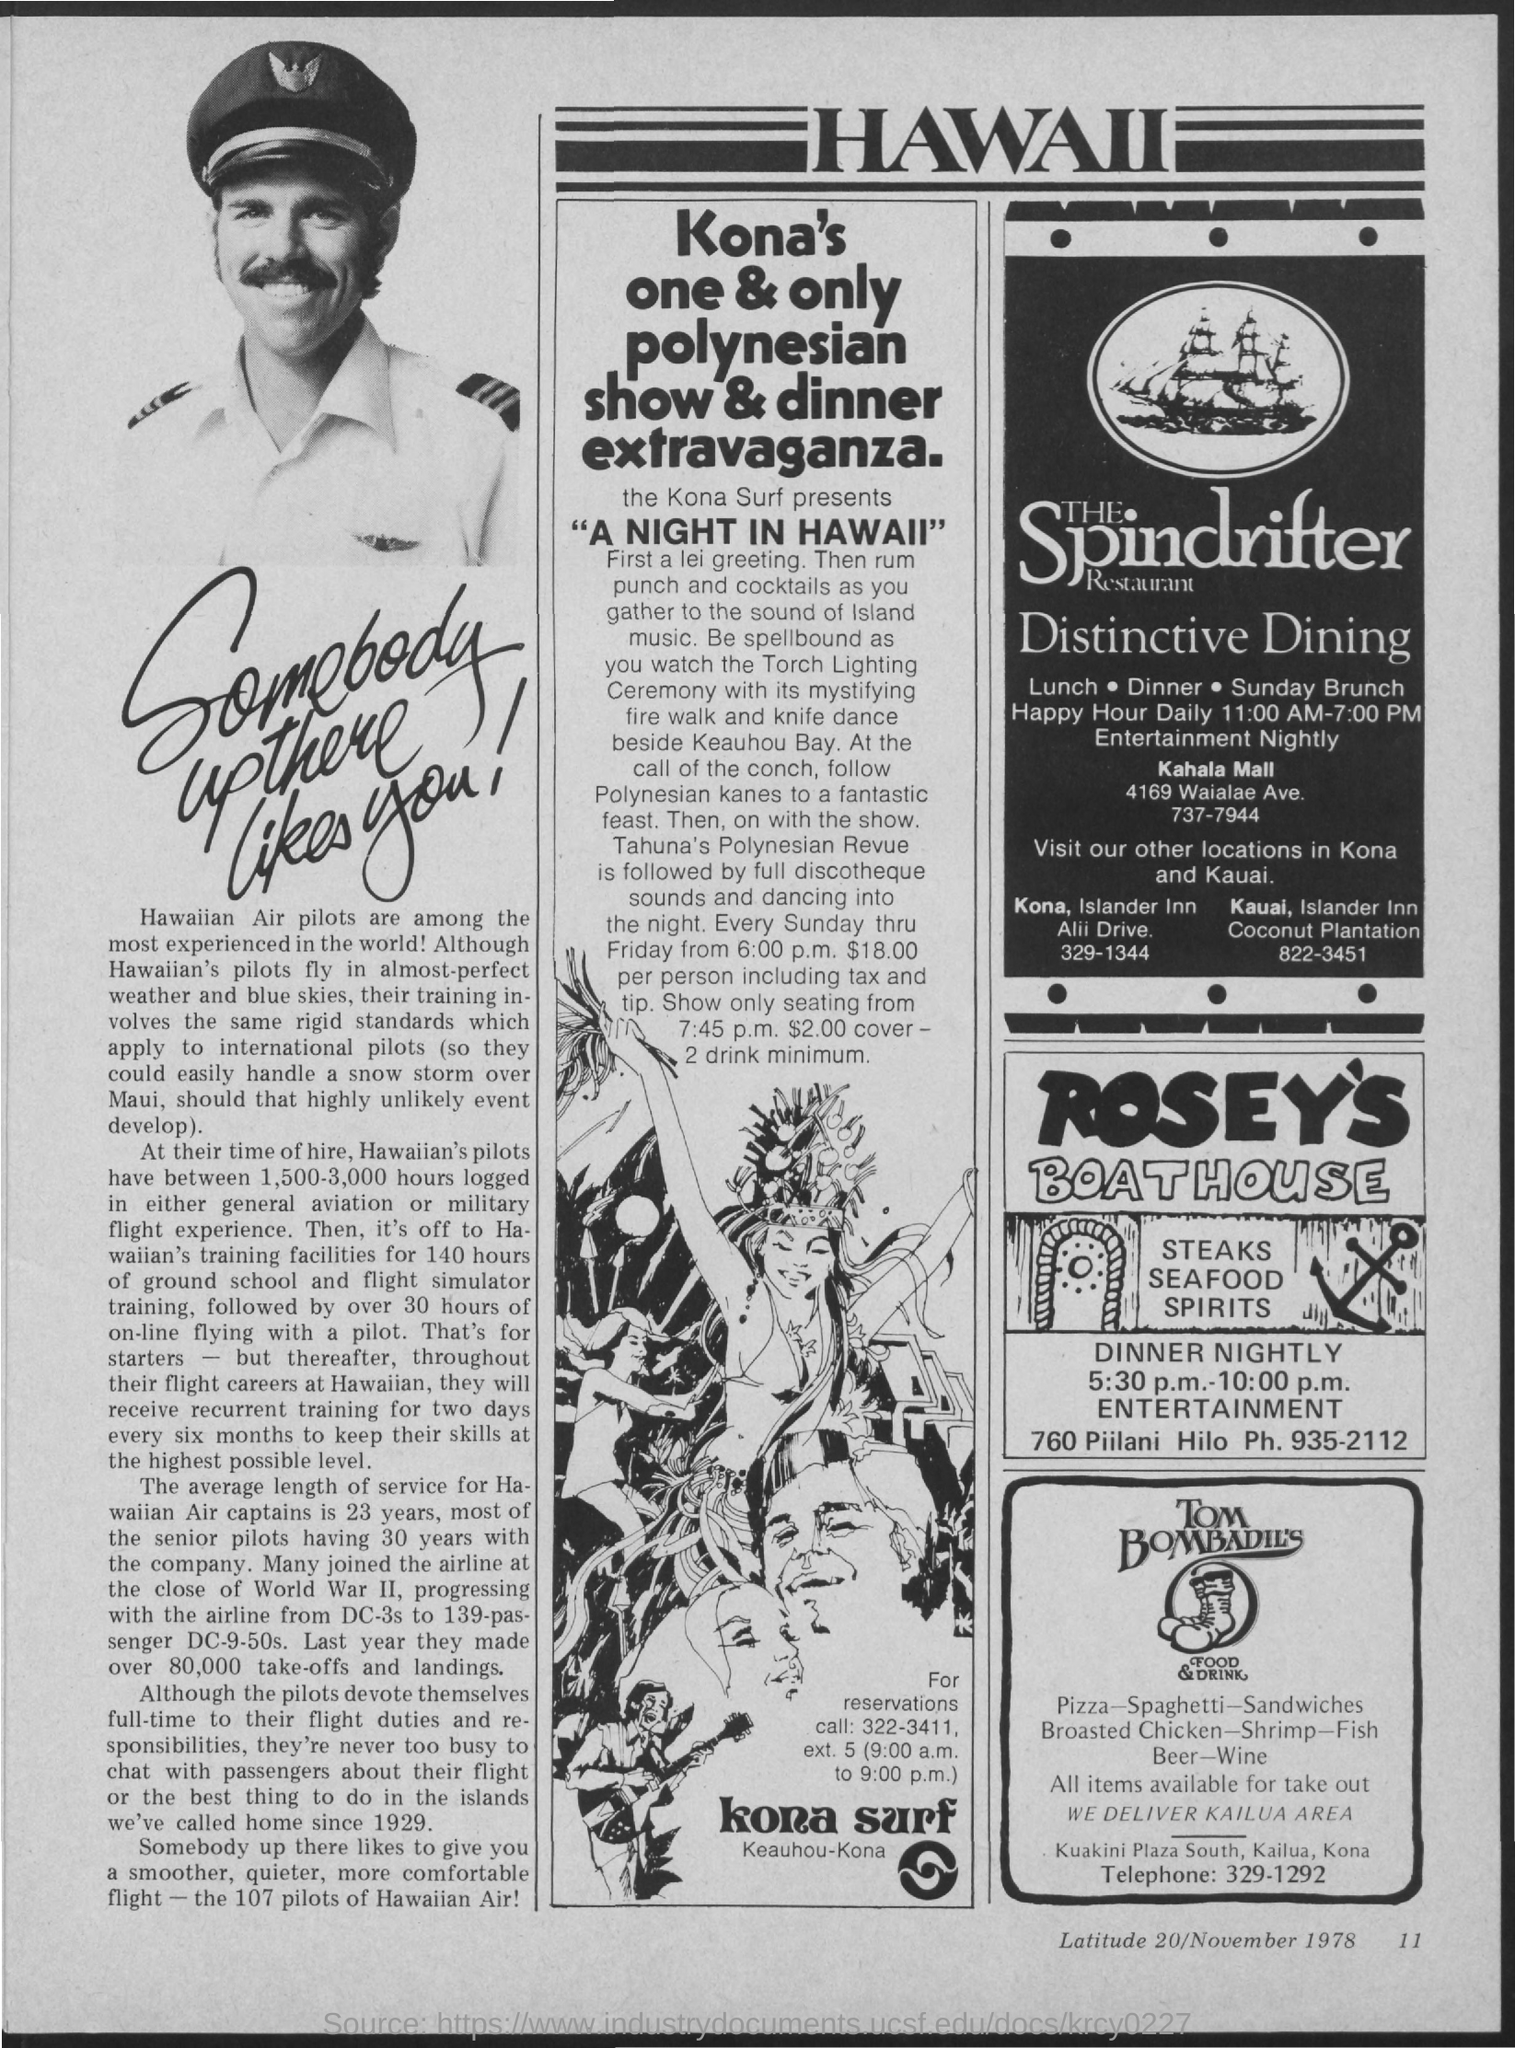What is phone number of rosey's boathouse ?
Offer a terse response. 935-2112. What is the heading on top of page?
Ensure brevity in your answer.  Hawaii. What is the tagline of the spindrifter restaurant?
Give a very brief answer. Distinctive dining. What is the telephone number of tom bombadil's  food & drink?
Provide a succinct answer. 329-1292. What is the page number at bottom of the page?
Keep it short and to the point. 11. 